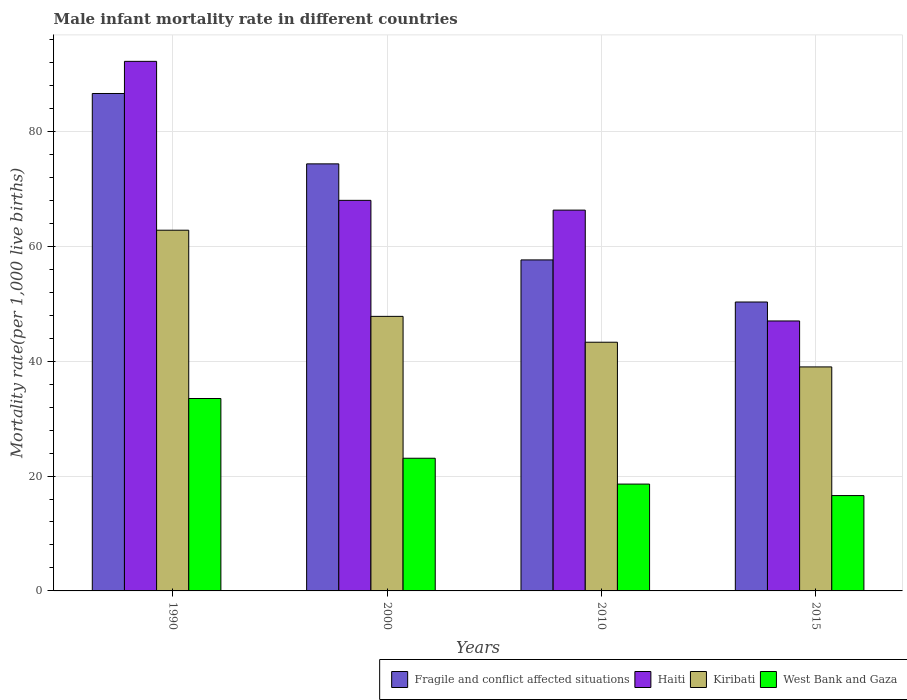How many different coloured bars are there?
Provide a short and direct response. 4. Are the number of bars per tick equal to the number of legend labels?
Your answer should be very brief. Yes. How many bars are there on the 4th tick from the right?
Your answer should be very brief. 4. What is the label of the 4th group of bars from the left?
Your answer should be very brief. 2015. In how many cases, is the number of bars for a given year not equal to the number of legend labels?
Keep it short and to the point. 0. Across all years, what is the maximum male infant mortality rate in Kiribati?
Ensure brevity in your answer.  62.8. Across all years, what is the minimum male infant mortality rate in West Bank and Gaza?
Keep it short and to the point. 16.6. In which year was the male infant mortality rate in Fragile and conflict affected situations maximum?
Keep it short and to the point. 1990. In which year was the male infant mortality rate in Kiribati minimum?
Make the answer very short. 2015. What is the total male infant mortality rate in Kiribati in the graph?
Provide a succinct answer. 192.9. What is the difference between the male infant mortality rate in Haiti in 2000 and that in 2015?
Provide a short and direct response. 21. What is the difference between the male infant mortality rate in Kiribati in 2010 and the male infant mortality rate in West Bank and Gaza in 1990?
Your response must be concise. 9.8. What is the average male infant mortality rate in Haiti per year?
Give a very brief answer. 68.38. In the year 1990, what is the difference between the male infant mortality rate in Kiribati and male infant mortality rate in Fragile and conflict affected situations?
Ensure brevity in your answer.  -23.8. In how many years, is the male infant mortality rate in West Bank and Gaza greater than 8?
Your response must be concise. 4. What is the ratio of the male infant mortality rate in West Bank and Gaza in 1990 to that in 2000?
Offer a very short reply. 1.45. Is the male infant mortality rate in Haiti in 2000 less than that in 2010?
Ensure brevity in your answer.  No. Is the difference between the male infant mortality rate in Kiribati in 1990 and 2000 greater than the difference between the male infant mortality rate in Fragile and conflict affected situations in 1990 and 2000?
Your response must be concise. Yes. What is the difference between the highest and the second highest male infant mortality rate in West Bank and Gaza?
Make the answer very short. 10.4. What is the difference between the highest and the lowest male infant mortality rate in Fragile and conflict affected situations?
Your response must be concise. 36.3. In how many years, is the male infant mortality rate in Haiti greater than the average male infant mortality rate in Haiti taken over all years?
Provide a succinct answer. 1. What does the 4th bar from the left in 1990 represents?
Keep it short and to the point. West Bank and Gaza. What does the 1st bar from the right in 2000 represents?
Ensure brevity in your answer.  West Bank and Gaza. How many bars are there?
Your response must be concise. 16. Are the values on the major ticks of Y-axis written in scientific E-notation?
Make the answer very short. No. Does the graph contain any zero values?
Keep it short and to the point. No. How many legend labels are there?
Offer a terse response. 4. What is the title of the graph?
Your answer should be very brief. Male infant mortality rate in different countries. Does "Tuvalu" appear as one of the legend labels in the graph?
Offer a very short reply. No. What is the label or title of the Y-axis?
Keep it short and to the point. Mortality rate(per 1,0 live births). What is the Mortality rate(per 1,000 live births) of Fragile and conflict affected situations in 1990?
Offer a terse response. 86.6. What is the Mortality rate(per 1,000 live births) of Haiti in 1990?
Give a very brief answer. 92.2. What is the Mortality rate(per 1,000 live births) in Kiribati in 1990?
Ensure brevity in your answer.  62.8. What is the Mortality rate(per 1,000 live births) in West Bank and Gaza in 1990?
Your answer should be very brief. 33.5. What is the Mortality rate(per 1,000 live births) of Fragile and conflict affected situations in 2000?
Ensure brevity in your answer.  74.35. What is the Mortality rate(per 1,000 live births) in Haiti in 2000?
Give a very brief answer. 68. What is the Mortality rate(per 1,000 live births) of Kiribati in 2000?
Provide a short and direct response. 47.8. What is the Mortality rate(per 1,000 live births) of West Bank and Gaza in 2000?
Your response must be concise. 23.1. What is the Mortality rate(per 1,000 live births) of Fragile and conflict affected situations in 2010?
Ensure brevity in your answer.  57.63. What is the Mortality rate(per 1,000 live births) in Haiti in 2010?
Offer a terse response. 66.3. What is the Mortality rate(per 1,000 live births) of Kiribati in 2010?
Provide a short and direct response. 43.3. What is the Mortality rate(per 1,000 live births) of West Bank and Gaza in 2010?
Offer a very short reply. 18.6. What is the Mortality rate(per 1,000 live births) of Fragile and conflict affected situations in 2015?
Provide a succinct answer. 50.3. Across all years, what is the maximum Mortality rate(per 1,000 live births) in Fragile and conflict affected situations?
Give a very brief answer. 86.6. Across all years, what is the maximum Mortality rate(per 1,000 live births) of Haiti?
Give a very brief answer. 92.2. Across all years, what is the maximum Mortality rate(per 1,000 live births) of Kiribati?
Provide a short and direct response. 62.8. Across all years, what is the maximum Mortality rate(per 1,000 live births) in West Bank and Gaza?
Keep it short and to the point. 33.5. Across all years, what is the minimum Mortality rate(per 1,000 live births) in Fragile and conflict affected situations?
Keep it short and to the point. 50.3. Across all years, what is the minimum Mortality rate(per 1,000 live births) of Kiribati?
Make the answer very short. 39. What is the total Mortality rate(per 1,000 live births) of Fragile and conflict affected situations in the graph?
Your answer should be very brief. 268.89. What is the total Mortality rate(per 1,000 live births) in Haiti in the graph?
Your answer should be compact. 273.5. What is the total Mortality rate(per 1,000 live births) in Kiribati in the graph?
Offer a very short reply. 192.9. What is the total Mortality rate(per 1,000 live births) of West Bank and Gaza in the graph?
Your response must be concise. 91.8. What is the difference between the Mortality rate(per 1,000 live births) of Fragile and conflict affected situations in 1990 and that in 2000?
Provide a succinct answer. 12.25. What is the difference between the Mortality rate(per 1,000 live births) in Haiti in 1990 and that in 2000?
Offer a very short reply. 24.2. What is the difference between the Mortality rate(per 1,000 live births) in Fragile and conflict affected situations in 1990 and that in 2010?
Provide a short and direct response. 28.97. What is the difference between the Mortality rate(per 1,000 live births) of Haiti in 1990 and that in 2010?
Provide a succinct answer. 25.9. What is the difference between the Mortality rate(per 1,000 live births) in Kiribati in 1990 and that in 2010?
Your response must be concise. 19.5. What is the difference between the Mortality rate(per 1,000 live births) of Fragile and conflict affected situations in 1990 and that in 2015?
Provide a succinct answer. 36.3. What is the difference between the Mortality rate(per 1,000 live births) in Haiti in 1990 and that in 2015?
Give a very brief answer. 45.2. What is the difference between the Mortality rate(per 1,000 live births) in Kiribati in 1990 and that in 2015?
Ensure brevity in your answer.  23.8. What is the difference between the Mortality rate(per 1,000 live births) of West Bank and Gaza in 1990 and that in 2015?
Keep it short and to the point. 16.9. What is the difference between the Mortality rate(per 1,000 live births) of Fragile and conflict affected situations in 2000 and that in 2010?
Your answer should be very brief. 16.72. What is the difference between the Mortality rate(per 1,000 live births) in Kiribati in 2000 and that in 2010?
Your response must be concise. 4.5. What is the difference between the Mortality rate(per 1,000 live births) in West Bank and Gaza in 2000 and that in 2010?
Keep it short and to the point. 4.5. What is the difference between the Mortality rate(per 1,000 live births) in Fragile and conflict affected situations in 2000 and that in 2015?
Offer a terse response. 24.05. What is the difference between the Mortality rate(per 1,000 live births) of Haiti in 2000 and that in 2015?
Your response must be concise. 21. What is the difference between the Mortality rate(per 1,000 live births) in Kiribati in 2000 and that in 2015?
Keep it short and to the point. 8.8. What is the difference between the Mortality rate(per 1,000 live births) in Fragile and conflict affected situations in 2010 and that in 2015?
Your response must be concise. 7.33. What is the difference between the Mortality rate(per 1,000 live births) in Haiti in 2010 and that in 2015?
Make the answer very short. 19.3. What is the difference between the Mortality rate(per 1,000 live births) of Fragile and conflict affected situations in 1990 and the Mortality rate(per 1,000 live births) of Haiti in 2000?
Your answer should be very brief. 18.6. What is the difference between the Mortality rate(per 1,000 live births) in Fragile and conflict affected situations in 1990 and the Mortality rate(per 1,000 live births) in Kiribati in 2000?
Offer a terse response. 38.8. What is the difference between the Mortality rate(per 1,000 live births) of Fragile and conflict affected situations in 1990 and the Mortality rate(per 1,000 live births) of West Bank and Gaza in 2000?
Provide a short and direct response. 63.5. What is the difference between the Mortality rate(per 1,000 live births) in Haiti in 1990 and the Mortality rate(per 1,000 live births) in Kiribati in 2000?
Make the answer very short. 44.4. What is the difference between the Mortality rate(per 1,000 live births) of Haiti in 1990 and the Mortality rate(per 1,000 live births) of West Bank and Gaza in 2000?
Your answer should be compact. 69.1. What is the difference between the Mortality rate(per 1,000 live births) in Kiribati in 1990 and the Mortality rate(per 1,000 live births) in West Bank and Gaza in 2000?
Your answer should be very brief. 39.7. What is the difference between the Mortality rate(per 1,000 live births) of Fragile and conflict affected situations in 1990 and the Mortality rate(per 1,000 live births) of Haiti in 2010?
Your answer should be very brief. 20.3. What is the difference between the Mortality rate(per 1,000 live births) of Fragile and conflict affected situations in 1990 and the Mortality rate(per 1,000 live births) of Kiribati in 2010?
Your response must be concise. 43.3. What is the difference between the Mortality rate(per 1,000 live births) in Fragile and conflict affected situations in 1990 and the Mortality rate(per 1,000 live births) in West Bank and Gaza in 2010?
Offer a terse response. 68. What is the difference between the Mortality rate(per 1,000 live births) in Haiti in 1990 and the Mortality rate(per 1,000 live births) in Kiribati in 2010?
Your response must be concise. 48.9. What is the difference between the Mortality rate(per 1,000 live births) in Haiti in 1990 and the Mortality rate(per 1,000 live births) in West Bank and Gaza in 2010?
Offer a terse response. 73.6. What is the difference between the Mortality rate(per 1,000 live births) in Kiribati in 1990 and the Mortality rate(per 1,000 live births) in West Bank and Gaza in 2010?
Your answer should be compact. 44.2. What is the difference between the Mortality rate(per 1,000 live births) of Fragile and conflict affected situations in 1990 and the Mortality rate(per 1,000 live births) of Haiti in 2015?
Ensure brevity in your answer.  39.6. What is the difference between the Mortality rate(per 1,000 live births) in Fragile and conflict affected situations in 1990 and the Mortality rate(per 1,000 live births) in Kiribati in 2015?
Make the answer very short. 47.6. What is the difference between the Mortality rate(per 1,000 live births) of Fragile and conflict affected situations in 1990 and the Mortality rate(per 1,000 live births) of West Bank and Gaza in 2015?
Your answer should be very brief. 70. What is the difference between the Mortality rate(per 1,000 live births) of Haiti in 1990 and the Mortality rate(per 1,000 live births) of Kiribati in 2015?
Provide a short and direct response. 53.2. What is the difference between the Mortality rate(per 1,000 live births) in Haiti in 1990 and the Mortality rate(per 1,000 live births) in West Bank and Gaza in 2015?
Offer a terse response. 75.6. What is the difference between the Mortality rate(per 1,000 live births) in Kiribati in 1990 and the Mortality rate(per 1,000 live births) in West Bank and Gaza in 2015?
Give a very brief answer. 46.2. What is the difference between the Mortality rate(per 1,000 live births) of Fragile and conflict affected situations in 2000 and the Mortality rate(per 1,000 live births) of Haiti in 2010?
Provide a succinct answer. 8.05. What is the difference between the Mortality rate(per 1,000 live births) of Fragile and conflict affected situations in 2000 and the Mortality rate(per 1,000 live births) of Kiribati in 2010?
Give a very brief answer. 31.05. What is the difference between the Mortality rate(per 1,000 live births) of Fragile and conflict affected situations in 2000 and the Mortality rate(per 1,000 live births) of West Bank and Gaza in 2010?
Your answer should be very brief. 55.75. What is the difference between the Mortality rate(per 1,000 live births) of Haiti in 2000 and the Mortality rate(per 1,000 live births) of Kiribati in 2010?
Provide a succinct answer. 24.7. What is the difference between the Mortality rate(per 1,000 live births) of Haiti in 2000 and the Mortality rate(per 1,000 live births) of West Bank and Gaza in 2010?
Keep it short and to the point. 49.4. What is the difference between the Mortality rate(per 1,000 live births) in Kiribati in 2000 and the Mortality rate(per 1,000 live births) in West Bank and Gaza in 2010?
Your response must be concise. 29.2. What is the difference between the Mortality rate(per 1,000 live births) in Fragile and conflict affected situations in 2000 and the Mortality rate(per 1,000 live births) in Haiti in 2015?
Make the answer very short. 27.35. What is the difference between the Mortality rate(per 1,000 live births) of Fragile and conflict affected situations in 2000 and the Mortality rate(per 1,000 live births) of Kiribati in 2015?
Keep it short and to the point. 35.35. What is the difference between the Mortality rate(per 1,000 live births) of Fragile and conflict affected situations in 2000 and the Mortality rate(per 1,000 live births) of West Bank and Gaza in 2015?
Keep it short and to the point. 57.75. What is the difference between the Mortality rate(per 1,000 live births) in Haiti in 2000 and the Mortality rate(per 1,000 live births) in West Bank and Gaza in 2015?
Your answer should be very brief. 51.4. What is the difference between the Mortality rate(per 1,000 live births) in Kiribati in 2000 and the Mortality rate(per 1,000 live births) in West Bank and Gaza in 2015?
Give a very brief answer. 31.2. What is the difference between the Mortality rate(per 1,000 live births) in Fragile and conflict affected situations in 2010 and the Mortality rate(per 1,000 live births) in Haiti in 2015?
Offer a very short reply. 10.63. What is the difference between the Mortality rate(per 1,000 live births) of Fragile and conflict affected situations in 2010 and the Mortality rate(per 1,000 live births) of Kiribati in 2015?
Your answer should be very brief. 18.63. What is the difference between the Mortality rate(per 1,000 live births) of Fragile and conflict affected situations in 2010 and the Mortality rate(per 1,000 live births) of West Bank and Gaza in 2015?
Your answer should be compact. 41.03. What is the difference between the Mortality rate(per 1,000 live births) in Haiti in 2010 and the Mortality rate(per 1,000 live births) in Kiribati in 2015?
Your response must be concise. 27.3. What is the difference between the Mortality rate(per 1,000 live births) of Haiti in 2010 and the Mortality rate(per 1,000 live births) of West Bank and Gaza in 2015?
Offer a terse response. 49.7. What is the difference between the Mortality rate(per 1,000 live births) in Kiribati in 2010 and the Mortality rate(per 1,000 live births) in West Bank and Gaza in 2015?
Your answer should be very brief. 26.7. What is the average Mortality rate(per 1,000 live births) in Fragile and conflict affected situations per year?
Offer a terse response. 67.22. What is the average Mortality rate(per 1,000 live births) of Haiti per year?
Your answer should be compact. 68.38. What is the average Mortality rate(per 1,000 live births) of Kiribati per year?
Give a very brief answer. 48.23. What is the average Mortality rate(per 1,000 live births) of West Bank and Gaza per year?
Keep it short and to the point. 22.95. In the year 1990, what is the difference between the Mortality rate(per 1,000 live births) in Fragile and conflict affected situations and Mortality rate(per 1,000 live births) in Haiti?
Make the answer very short. -5.6. In the year 1990, what is the difference between the Mortality rate(per 1,000 live births) in Fragile and conflict affected situations and Mortality rate(per 1,000 live births) in Kiribati?
Offer a very short reply. 23.8. In the year 1990, what is the difference between the Mortality rate(per 1,000 live births) in Fragile and conflict affected situations and Mortality rate(per 1,000 live births) in West Bank and Gaza?
Your response must be concise. 53.1. In the year 1990, what is the difference between the Mortality rate(per 1,000 live births) of Haiti and Mortality rate(per 1,000 live births) of Kiribati?
Ensure brevity in your answer.  29.4. In the year 1990, what is the difference between the Mortality rate(per 1,000 live births) in Haiti and Mortality rate(per 1,000 live births) in West Bank and Gaza?
Your response must be concise. 58.7. In the year 1990, what is the difference between the Mortality rate(per 1,000 live births) of Kiribati and Mortality rate(per 1,000 live births) of West Bank and Gaza?
Your answer should be very brief. 29.3. In the year 2000, what is the difference between the Mortality rate(per 1,000 live births) of Fragile and conflict affected situations and Mortality rate(per 1,000 live births) of Haiti?
Make the answer very short. 6.35. In the year 2000, what is the difference between the Mortality rate(per 1,000 live births) of Fragile and conflict affected situations and Mortality rate(per 1,000 live births) of Kiribati?
Ensure brevity in your answer.  26.55. In the year 2000, what is the difference between the Mortality rate(per 1,000 live births) in Fragile and conflict affected situations and Mortality rate(per 1,000 live births) in West Bank and Gaza?
Keep it short and to the point. 51.25. In the year 2000, what is the difference between the Mortality rate(per 1,000 live births) of Haiti and Mortality rate(per 1,000 live births) of Kiribati?
Offer a very short reply. 20.2. In the year 2000, what is the difference between the Mortality rate(per 1,000 live births) in Haiti and Mortality rate(per 1,000 live births) in West Bank and Gaza?
Give a very brief answer. 44.9. In the year 2000, what is the difference between the Mortality rate(per 1,000 live births) of Kiribati and Mortality rate(per 1,000 live births) of West Bank and Gaza?
Offer a terse response. 24.7. In the year 2010, what is the difference between the Mortality rate(per 1,000 live births) in Fragile and conflict affected situations and Mortality rate(per 1,000 live births) in Haiti?
Ensure brevity in your answer.  -8.67. In the year 2010, what is the difference between the Mortality rate(per 1,000 live births) of Fragile and conflict affected situations and Mortality rate(per 1,000 live births) of Kiribati?
Offer a terse response. 14.33. In the year 2010, what is the difference between the Mortality rate(per 1,000 live births) in Fragile and conflict affected situations and Mortality rate(per 1,000 live births) in West Bank and Gaza?
Your answer should be very brief. 39.03. In the year 2010, what is the difference between the Mortality rate(per 1,000 live births) in Haiti and Mortality rate(per 1,000 live births) in West Bank and Gaza?
Provide a succinct answer. 47.7. In the year 2010, what is the difference between the Mortality rate(per 1,000 live births) of Kiribati and Mortality rate(per 1,000 live births) of West Bank and Gaza?
Provide a succinct answer. 24.7. In the year 2015, what is the difference between the Mortality rate(per 1,000 live births) in Fragile and conflict affected situations and Mortality rate(per 1,000 live births) in Haiti?
Provide a succinct answer. 3.3. In the year 2015, what is the difference between the Mortality rate(per 1,000 live births) of Fragile and conflict affected situations and Mortality rate(per 1,000 live births) of Kiribati?
Provide a succinct answer. 11.3. In the year 2015, what is the difference between the Mortality rate(per 1,000 live births) in Fragile and conflict affected situations and Mortality rate(per 1,000 live births) in West Bank and Gaza?
Make the answer very short. 33.7. In the year 2015, what is the difference between the Mortality rate(per 1,000 live births) of Haiti and Mortality rate(per 1,000 live births) of Kiribati?
Your response must be concise. 8. In the year 2015, what is the difference between the Mortality rate(per 1,000 live births) in Haiti and Mortality rate(per 1,000 live births) in West Bank and Gaza?
Offer a very short reply. 30.4. In the year 2015, what is the difference between the Mortality rate(per 1,000 live births) of Kiribati and Mortality rate(per 1,000 live births) of West Bank and Gaza?
Provide a short and direct response. 22.4. What is the ratio of the Mortality rate(per 1,000 live births) of Fragile and conflict affected situations in 1990 to that in 2000?
Ensure brevity in your answer.  1.16. What is the ratio of the Mortality rate(per 1,000 live births) in Haiti in 1990 to that in 2000?
Your response must be concise. 1.36. What is the ratio of the Mortality rate(per 1,000 live births) in Kiribati in 1990 to that in 2000?
Ensure brevity in your answer.  1.31. What is the ratio of the Mortality rate(per 1,000 live births) of West Bank and Gaza in 1990 to that in 2000?
Provide a short and direct response. 1.45. What is the ratio of the Mortality rate(per 1,000 live births) in Fragile and conflict affected situations in 1990 to that in 2010?
Your response must be concise. 1.5. What is the ratio of the Mortality rate(per 1,000 live births) in Haiti in 1990 to that in 2010?
Keep it short and to the point. 1.39. What is the ratio of the Mortality rate(per 1,000 live births) in Kiribati in 1990 to that in 2010?
Your answer should be very brief. 1.45. What is the ratio of the Mortality rate(per 1,000 live births) of West Bank and Gaza in 1990 to that in 2010?
Ensure brevity in your answer.  1.8. What is the ratio of the Mortality rate(per 1,000 live births) in Fragile and conflict affected situations in 1990 to that in 2015?
Offer a very short reply. 1.72. What is the ratio of the Mortality rate(per 1,000 live births) of Haiti in 1990 to that in 2015?
Offer a terse response. 1.96. What is the ratio of the Mortality rate(per 1,000 live births) of Kiribati in 1990 to that in 2015?
Your answer should be very brief. 1.61. What is the ratio of the Mortality rate(per 1,000 live births) in West Bank and Gaza in 1990 to that in 2015?
Your answer should be very brief. 2.02. What is the ratio of the Mortality rate(per 1,000 live births) of Fragile and conflict affected situations in 2000 to that in 2010?
Offer a terse response. 1.29. What is the ratio of the Mortality rate(per 1,000 live births) in Haiti in 2000 to that in 2010?
Your answer should be compact. 1.03. What is the ratio of the Mortality rate(per 1,000 live births) of Kiribati in 2000 to that in 2010?
Ensure brevity in your answer.  1.1. What is the ratio of the Mortality rate(per 1,000 live births) of West Bank and Gaza in 2000 to that in 2010?
Offer a very short reply. 1.24. What is the ratio of the Mortality rate(per 1,000 live births) of Fragile and conflict affected situations in 2000 to that in 2015?
Provide a succinct answer. 1.48. What is the ratio of the Mortality rate(per 1,000 live births) of Haiti in 2000 to that in 2015?
Make the answer very short. 1.45. What is the ratio of the Mortality rate(per 1,000 live births) in Kiribati in 2000 to that in 2015?
Your answer should be very brief. 1.23. What is the ratio of the Mortality rate(per 1,000 live births) of West Bank and Gaza in 2000 to that in 2015?
Ensure brevity in your answer.  1.39. What is the ratio of the Mortality rate(per 1,000 live births) of Fragile and conflict affected situations in 2010 to that in 2015?
Your answer should be compact. 1.15. What is the ratio of the Mortality rate(per 1,000 live births) in Haiti in 2010 to that in 2015?
Keep it short and to the point. 1.41. What is the ratio of the Mortality rate(per 1,000 live births) in Kiribati in 2010 to that in 2015?
Your answer should be compact. 1.11. What is the ratio of the Mortality rate(per 1,000 live births) in West Bank and Gaza in 2010 to that in 2015?
Ensure brevity in your answer.  1.12. What is the difference between the highest and the second highest Mortality rate(per 1,000 live births) in Fragile and conflict affected situations?
Your response must be concise. 12.25. What is the difference between the highest and the second highest Mortality rate(per 1,000 live births) in Haiti?
Keep it short and to the point. 24.2. What is the difference between the highest and the lowest Mortality rate(per 1,000 live births) of Fragile and conflict affected situations?
Give a very brief answer. 36.3. What is the difference between the highest and the lowest Mortality rate(per 1,000 live births) in Haiti?
Provide a short and direct response. 45.2. What is the difference between the highest and the lowest Mortality rate(per 1,000 live births) in Kiribati?
Ensure brevity in your answer.  23.8. What is the difference between the highest and the lowest Mortality rate(per 1,000 live births) in West Bank and Gaza?
Your answer should be very brief. 16.9. 